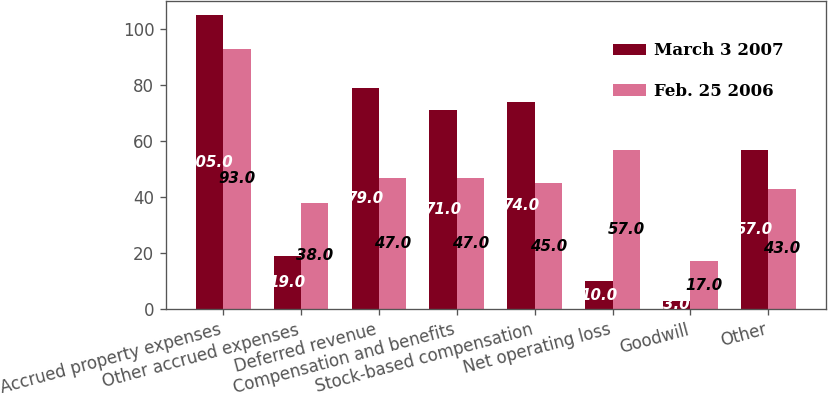Convert chart. <chart><loc_0><loc_0><loc_500><loc_500><stacked_bar_chart><ecel><fcel>Accrued property expenses<fcel>Other accrued expenses<fcel>Deferred revenue<fcel>Compensation and benefits<fcel>Stock-based compensation<fcel>Net operating loss<fcel>Goodwill<fcel>Other<nl><fcel>March 3 2007<fcel>105<fcel>19<fcel>79<fcel>71<fcel>74<fcel>10<fcel>3<fcel>57<nl><fcel>Feb. 25 2006<fcel>93<fcel>38<fcel>47<fcel>47<fcel>45<fcel>57<fcel>17<fcel>43<nl></chart> 